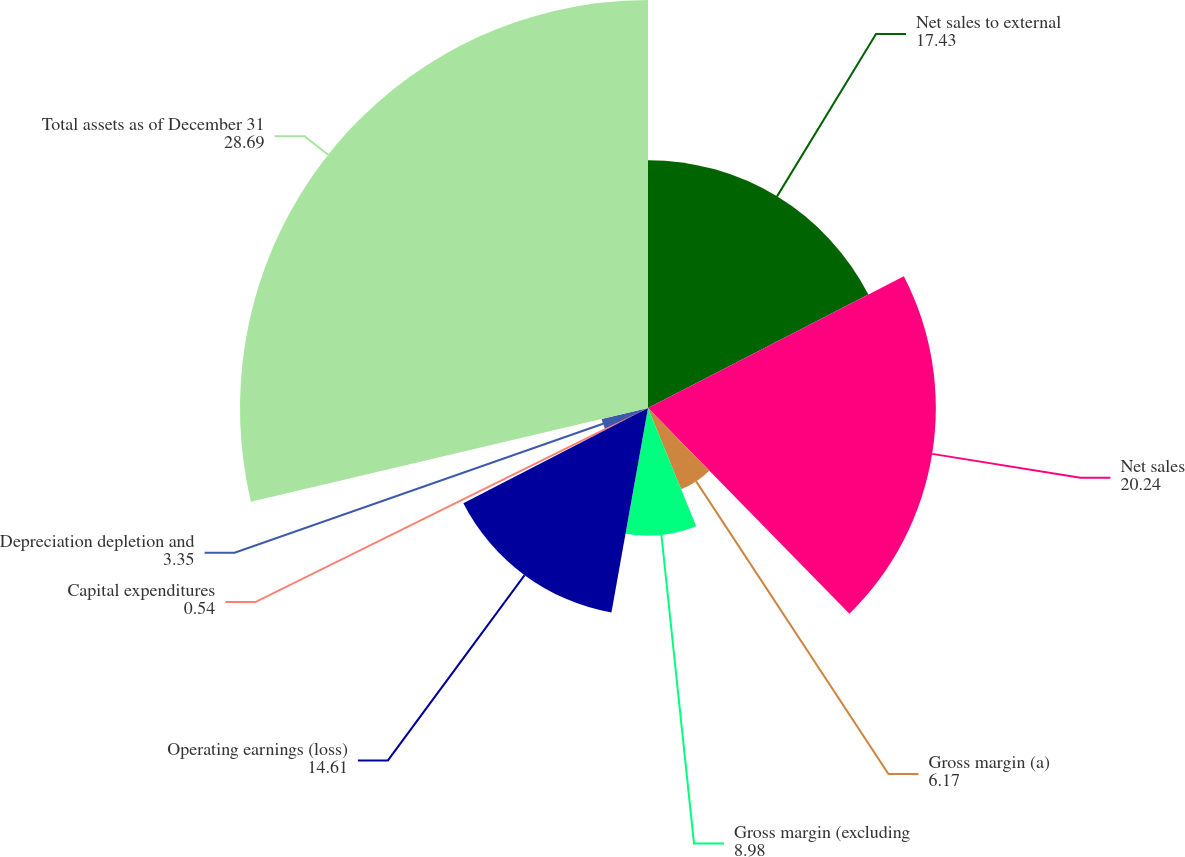Convert chart. <chart><loc_0><loc_0><loc_500><loc_500><pie_chart><fcel>Net sales to external<fcel>Net sales<fcel>Gross margin (a)<fcel>Gross margin (excluding<fcel>Operating earnings (loss)<fcel>Capital expenditures<fcel>Depreciation depletion and<fcel>Total assets as of December 31<nl><fcel>17.43%<fcel>20.24%<fcel>6.17%<fcel>8.98%<fcel>14.61%<fcel>0.54%<fcel>3.35%<fcel>28.69%<nl></chart> 